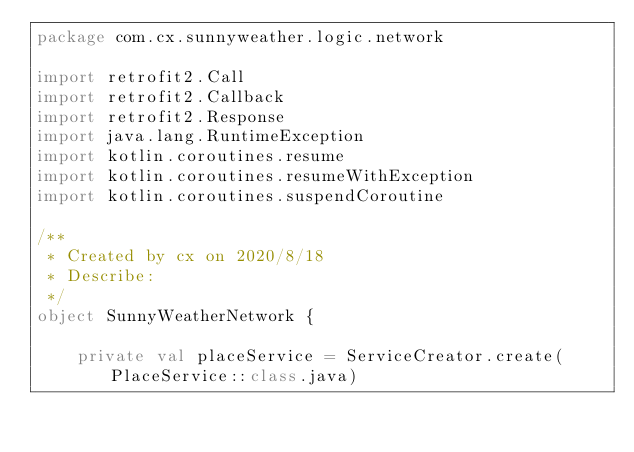<code> <loc_0><loc_0><loc_500><loc_500><_Kotlin_>package com.cx.sunnyweather.logic.network

import retrofit2.Call
import retrofit2.Callback
import retrofit2.Response
import java.lang.RuntimeException
import kotlin.coroutines.resume
import kotlin.coroutines.resumeWithException
import kotlin.coroutines.suspendCoroutine

/**
 * Created by cx on 2020/8/18
 * Describe:
 */
object SunnyWeatherNetwork {

    private val placeService = ServiceCreator.create(PlaceService::class.java)</code> 